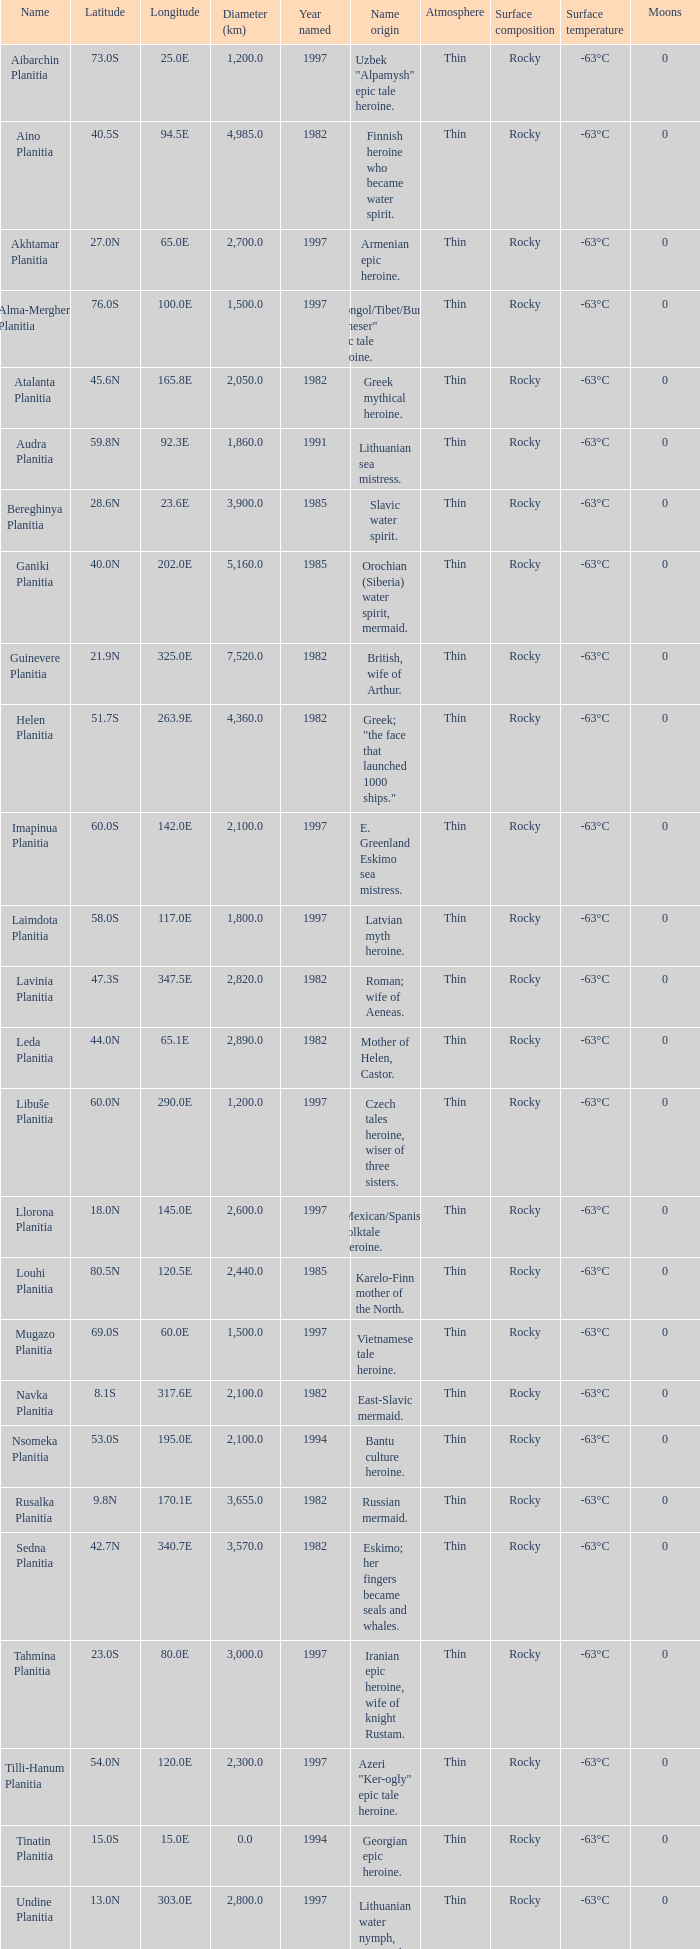What's the name origin of feature of diameter (km) 2,155.0 Karelo-Finn mermaid. 